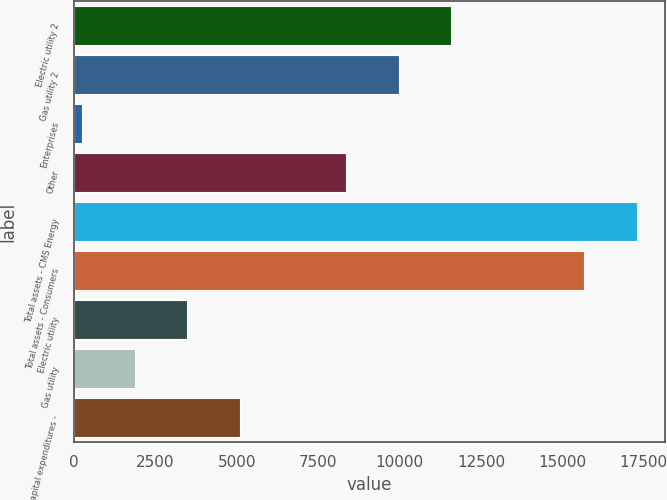Convert chart. <chart><loc_0><loc_0><loc_500><loc_500><bar_chart><fcel>Electric utility 2<fcel>Gas utility 2<fcel>Enterprises<fcel>Other<fcel>Total assets - CMS Energy<fcel>Total assets - Consumers<fcel>Electric utility<fcel>Gas utility<fcel>Total capital expenditures -<nl><fcel>11589<fcel>9968<fcel>242<fcel>8347<fcel>17283<fcel>15662<fcel>3484<fcel>1863<fcel>5105<nl></chart> 